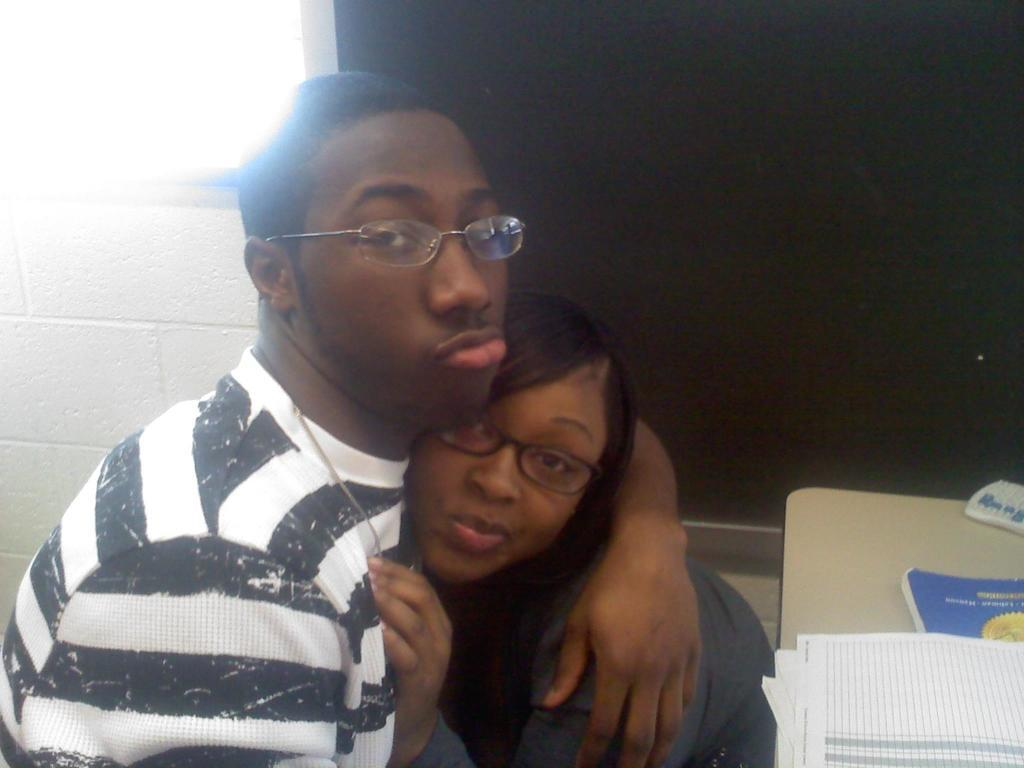Who are the people in the image? There is a man and a woman in the image. What object can be seen on a surface in the image? There is a book on a surface in the image. What else is on the same surface as the book? There are papers on the same surface. What type of trucks can be seen in the image? There are no trucks present in the image. How does the sand appear in the image? There is no sand present in the image. 